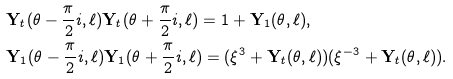Convert formula to latex. <formula><loc_0><loc_0><loc_500><loc_500>& { \mathbf Y } _ { t } ( \theta - \frac { \pi } { 2 } i , \ell ) { \mathbf Y } _ { t } ( \theta + \frac { \pi } { 2 } i , \ell ) = 1 + { \mathbf Y } _ { 1 } ( \theta , \ell ) , \\ & { \mathbf Y } _ { 1 } ( \theta - \frac { \pi } { 2 } i , \ell ) { \mathbf Y } _ { 1 } ( \theta + \frac { \pi } { 2 } i , \ell ) = ( \xi ^ { 3 } + { \mathbf Y } _ { t } ( \theta , \ell ) ) ( \xi ^ { - 3 } + { \mathbf Y } _ { t } ( \theta , \ell ) ) .</formula> 